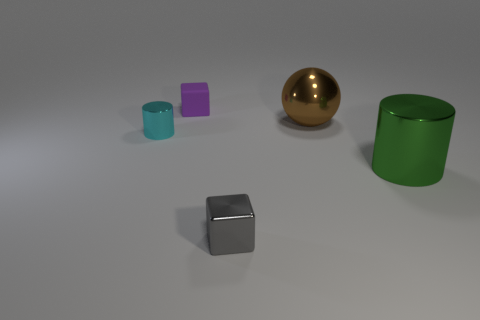What color is the metallic cylinder that is the same size as the purple rubber thing?
Your response must be concise. Cyan. How many big brown shiny things are the same shape as the tiny purple rubber object?
Offer a very short reply. 0. Is the cylinder that is on the left side of the tiny gray thing made of the same material as the green thing?
Provide a succinct answer. Yes. How many cylinders are gray shiny objects or purple matte objects?
Give a very brief answer. 0. There is a big green thing to the right of the shiny thing on the left side of the small block that is behind the gray cube; what shape is it?
Offer a terse response. Cylinder. How many purple matte things are the same size as the cyan cylinder?
Ensure brevity in your answer.  1. There is a shiny cylinder on the left side of the tiny gray block; are there any tiny cyan cylinders to the left of it?
Keep it short and to the point. No. What number of things are small gray blocks or green cylinders?
Provide a short and direct response. 2. There is a cylinder that is behind the shiny cylinder in front of the cylinder that is left of the tiny purple matte cube; what is its color?
Ensure brevity in your answer.  Cyan. Is there any other thing of the same color as the small rubber block?
Offer a terse response. No. 